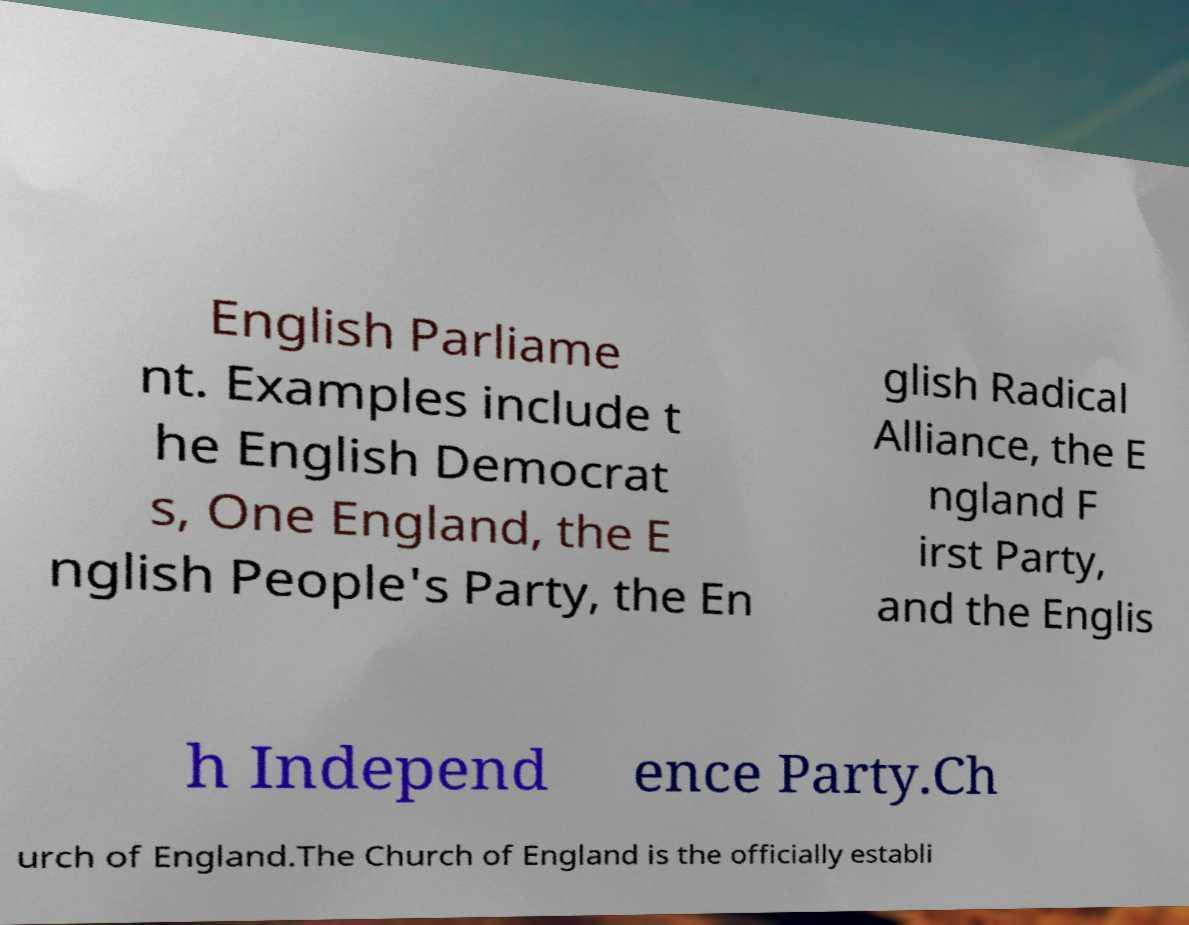There's text embedded in this image that I need extracted. Can you transcribe it verbatim? English Parliame nt. Examples include t he English Democrat s, One England, the E nglish People's Party, the En glish Radical Alliance, the E ngland F irst Party, and the Englis h Independ ence Party.Ch urch of England.The Church of England is the officially establi 